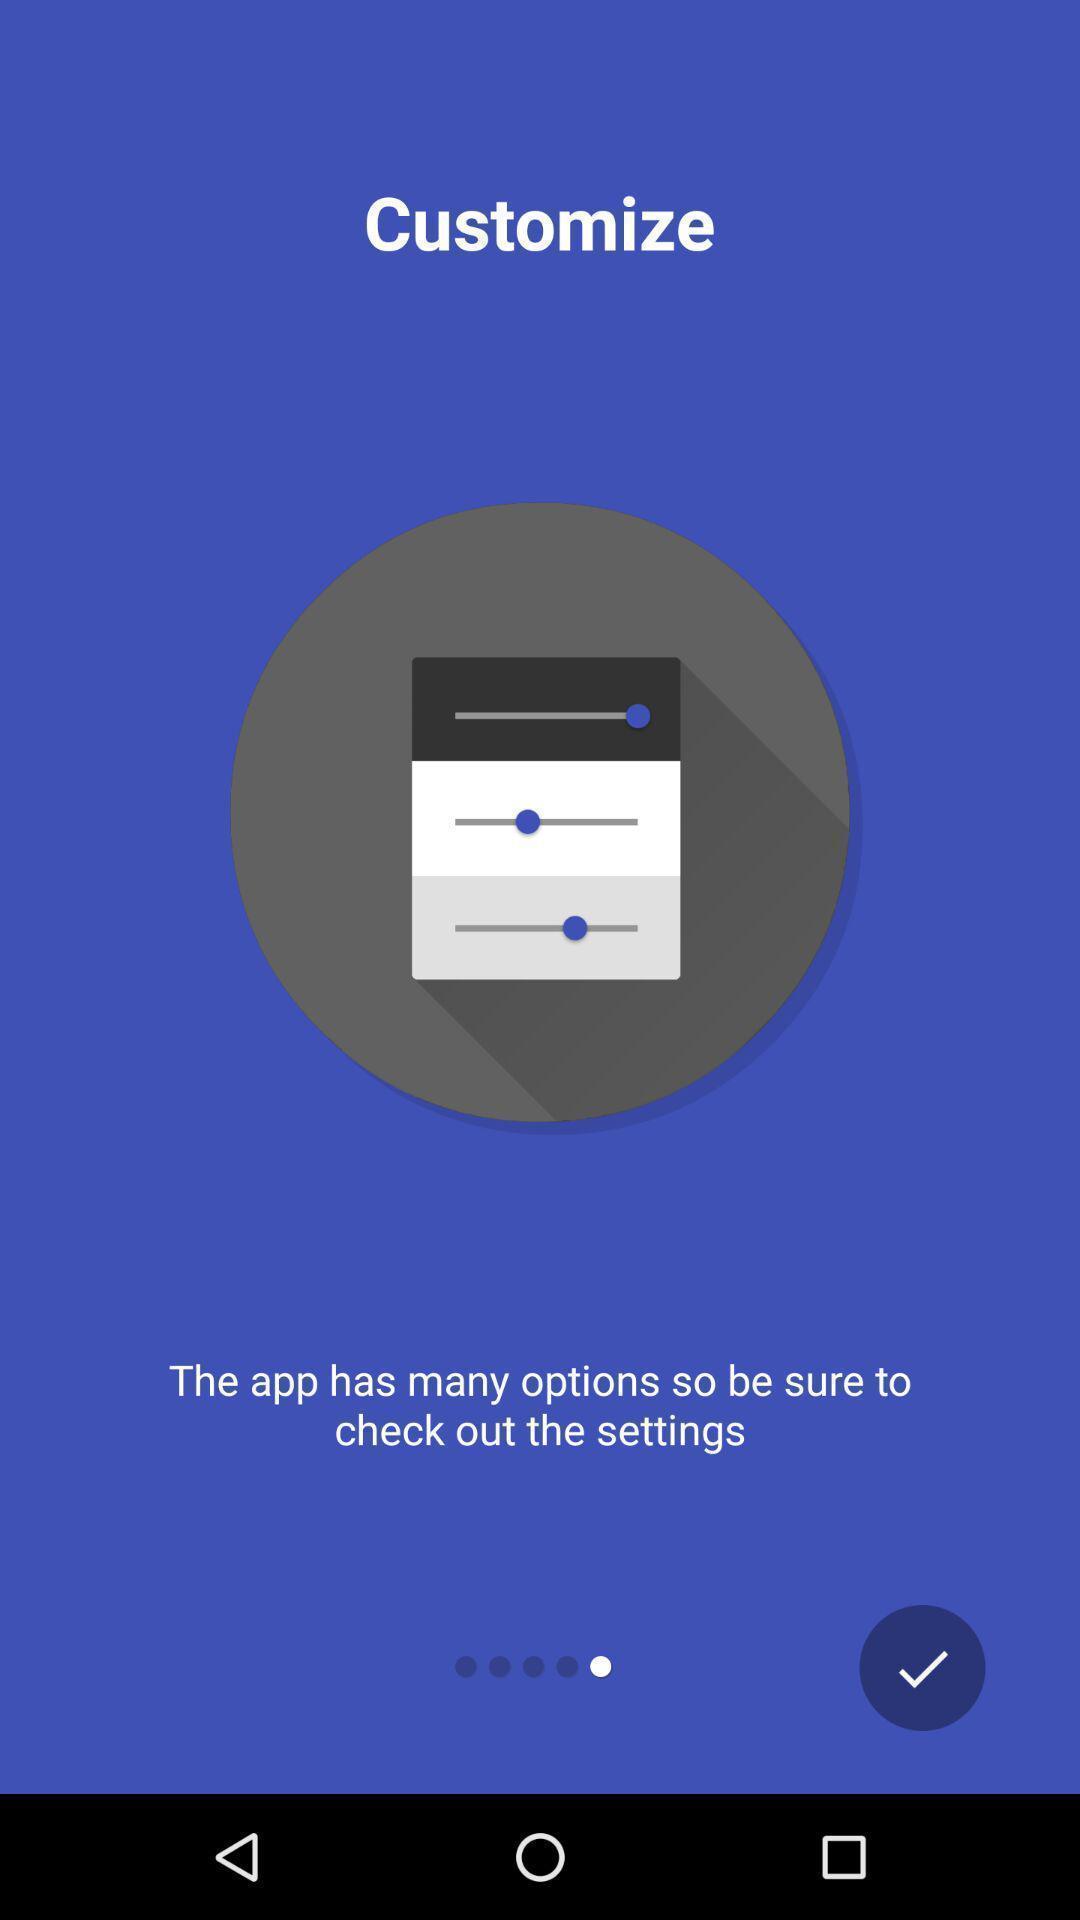Give me a summary of this screen capture. Welcome page displayed. 